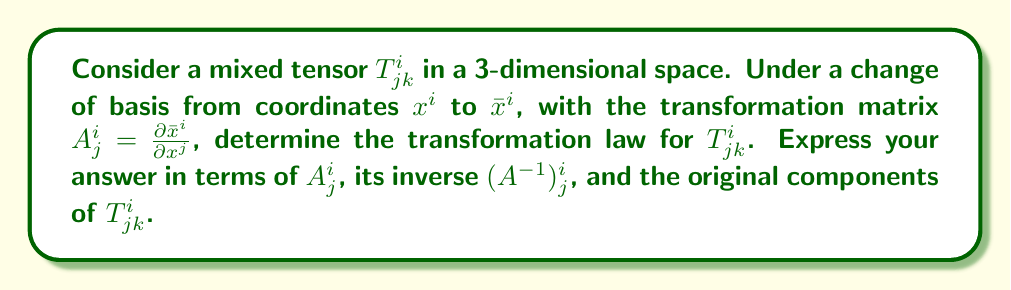Could you help me with this problem? 1. Recall the transformation rules for contravariant and covariant tensors:
   - Contravariant: $\bar{T}^i = A^i_j T^j$
   - Covariant: $\bar{T}_i = (A^{-1})^j_i T_j$

2. For a mixed tensor $T^i_{jk}$, we apply these rules to each index:
   - The upper index $i$ transforms contravariantly
   - The lower indices $j$ and $k$ transform covariantly

3. Let's transform each index step by step:
   a) Transform the upper index $i$:
      $\bar{T}^i_{jk} = A^i_l T^l_{jk}$
   
   b) Transform the first lower index $j$:
      $\bar{T}^i_{jk} = A^i_l (A^{-1})^m_j T^l_{mk}$
   
   c) Transform the second lower index $k$:
      $\bar{T}^i_{jk} = A^i_l (A^{-1})^m_j (A^{-1})^n_k T^l_{mn}$

4. This final expression represents the complete transformation law for the mixed tensor $T^i_{jk}$.

5. To verify, we can check that the number of free indices (i, j, k) and summed indices (l, m, n) match on both sides of the equation.
Answer: $\bar{T}^i_{jk} = A^i_l (A^{-1})^m_j (A^{-1})^n_k T^l_{mn}$ 